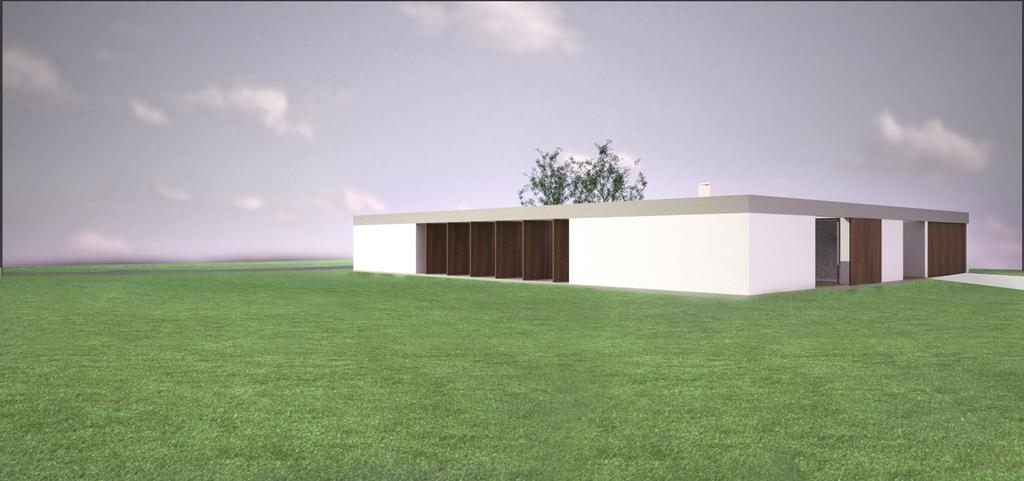What type of structure is present in the animation? There is a house in the animation. What natural element is also present in the animation? There is a tree in the animation. What can be seen in the sky in the animation? There are clouds in the sky in the animation. What is visible at the bottom of the animation? There is ground visible in the animation. What advice does the tree give to the house in the animation? There is no dialogue or interaction between the tree and the house in the animation, so no advice is given. How does the flock of birds move in the animation? There is no mention of birds or a flock in the provided facts, so we cannot answer this question. 